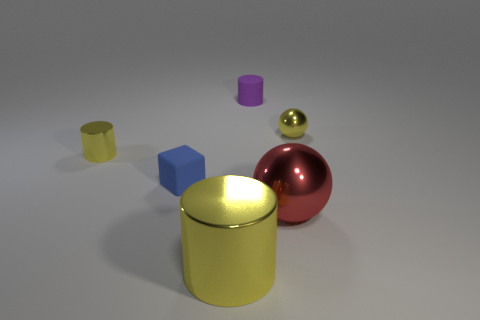Subtract all brown cubes. How many yellow cylinders are left? 2 Subtract 1 cylinders. How many cylinders are left? 2 Add 2 big shiny cylinders. How many objects exist? 8 Subtract all balls. How many objects are left? 4 Subtract all spheres. Subtract all large yellow cylinders. How many objects are left? 3 Add 6 blocks. How many blocks are left? 7 Add 2 tiny purple metallic cylinders. How many tiny purple metallic cylinders exist? 2 Subtract 0 green spheres. How many objects are left? 6 